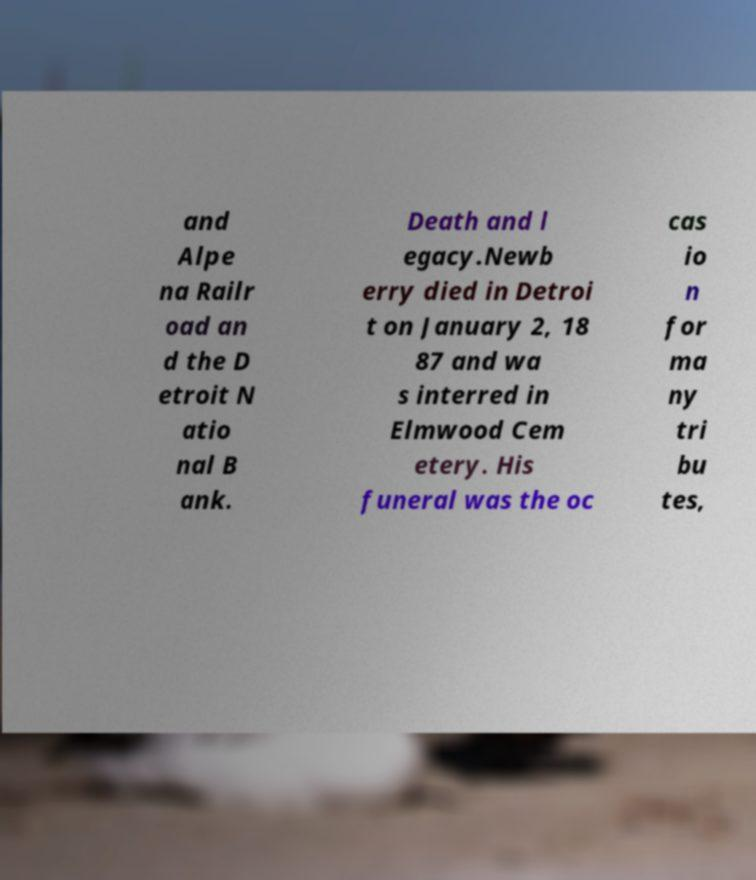Can you accurately transcribe the text from the provided image for me? and Alpe na Railr oad an d the D etroit N atio nal B ank. Death and l egacy.Newb erry died in Detroi t on January 2, 18 87 and wa s interred in Elmwood Cem etery. His funeral was the oc cas io n for ma ny tri bu tes, 